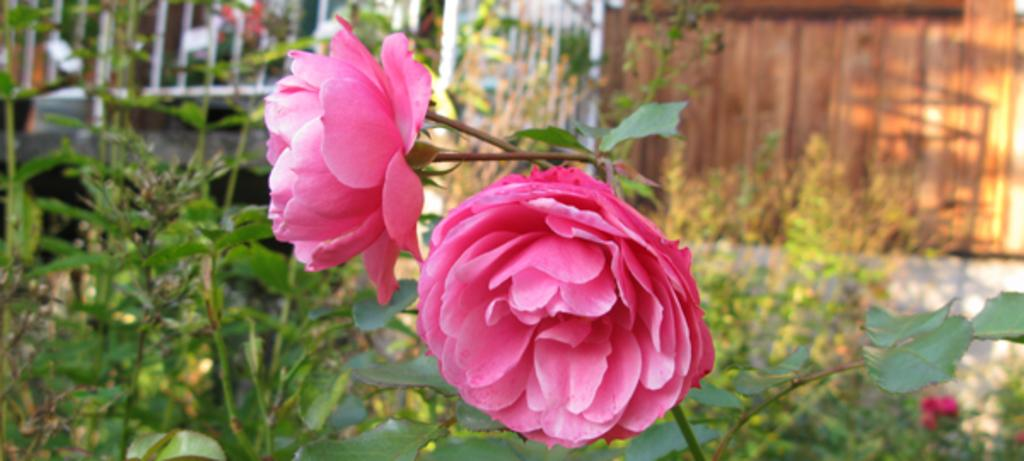What type of living organisms can be seen in the image? Plants and flowers are visible in the image. What material is the wall in the background of the image made of? The wall in the background of the image is made of wood. What is located on the left side of the image? There is a metal fence on the left side of the image. How much dust can be seen on the table in the image? There is no table present in the image, so it is not possible to determine the amount of dust on it. 